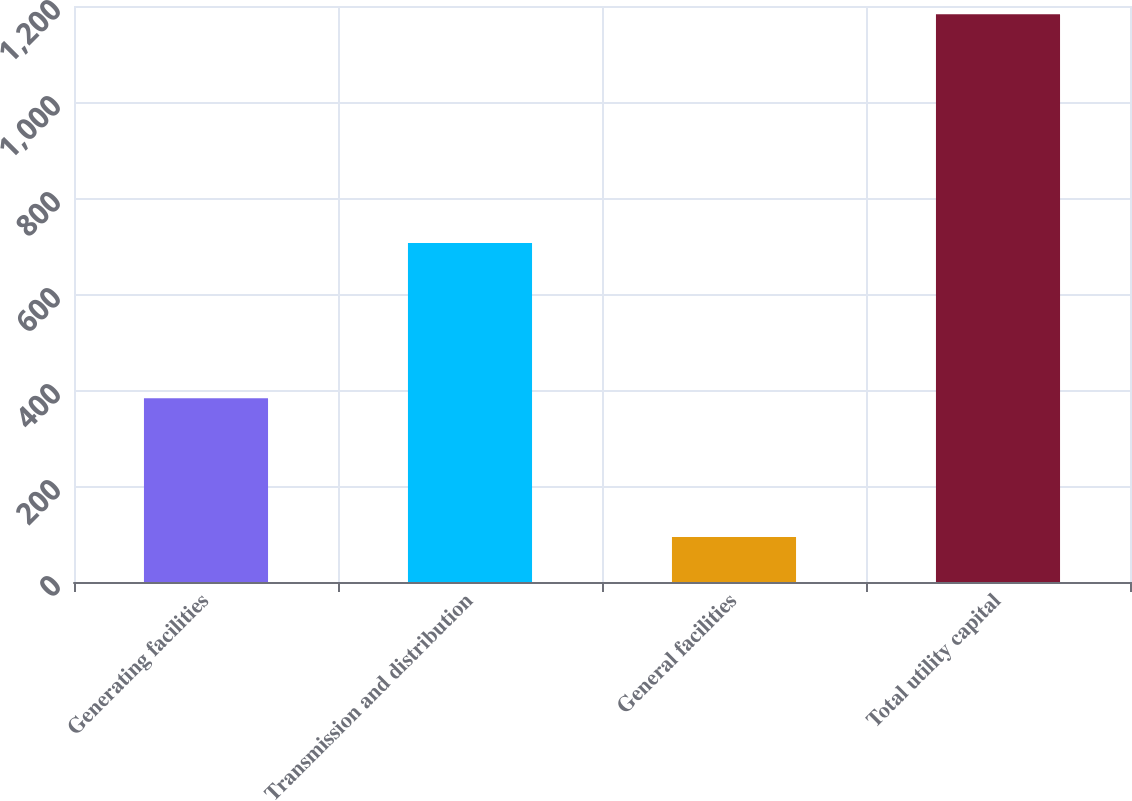<chart> <loc_0><loc_0><loc_500><loc_500><bar_chart><fcel>Generating facilities<fcel>Transmission and distribution<fcel>General facilities<fcel>Total utility capital<nl><fcel>383<fcel>706<fcel>94<fcel>1183<nl></chart> 